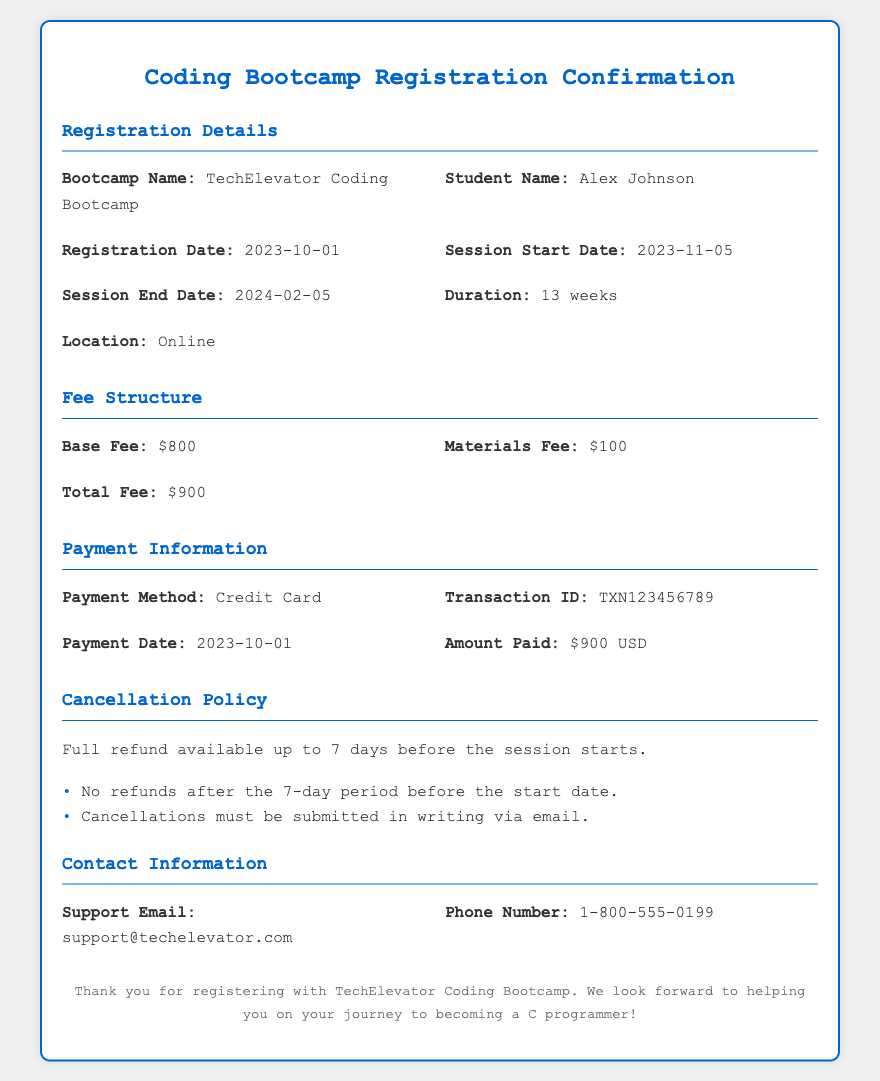what is the name of the bootcamp? The bootcamp name is mentioned clearly in the document under 'Bootcamp Name'.
Answer: TechElevator Coding Bootcamp who is the student registered? The student's name is stated in the 'Student Name' section of the document.
Answer: Alex Johnson when does the session start? The start date of the session is specified under 'Session Start Date'.
Answer: 2023-11-05 how much is the total fee? The total fee is listed under 'Total Fee' in the document.
Answer: $900 what is the cancellation policy regarding refunds? The document specifies the refund policy, particularly noting the availability of full refunds under certain conditions.
Answer: Full refund available up to 7 days before the session starts what is the payment method used? The payment method is provided under 'Payment Method' in the payment information section.
Answer: Credit Card what is the duration of the bootcamp? The duration of the bootcamp is noted in the 'Duration' section of the document.
Answer: 13 weeks what must be done to cancel a registration? The document outlines the necessary action for cancellations in its cancellation policy.
Answer: Cancellations must be submitted in writing via email when was the payment made? The payment date is specified in the 'Payment Information' section.
Answer: 2023-10-01 